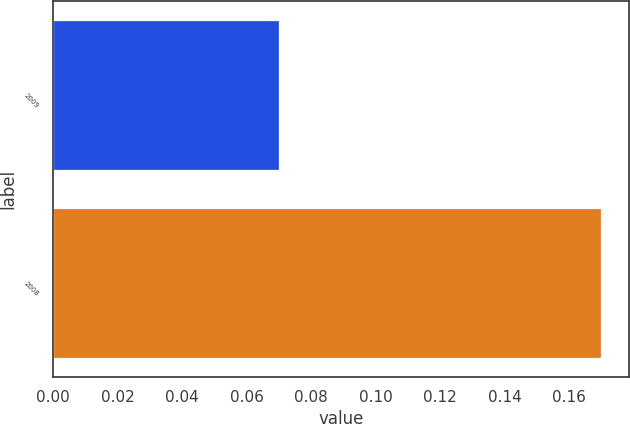Convert chart to OTSL. <chart><loc_0><loc_0><loc_500><loc_500><bar_chart><fcel>2009<fcel>2008<nl><fcel>0.07<fcel>0.17<nl></chart> 